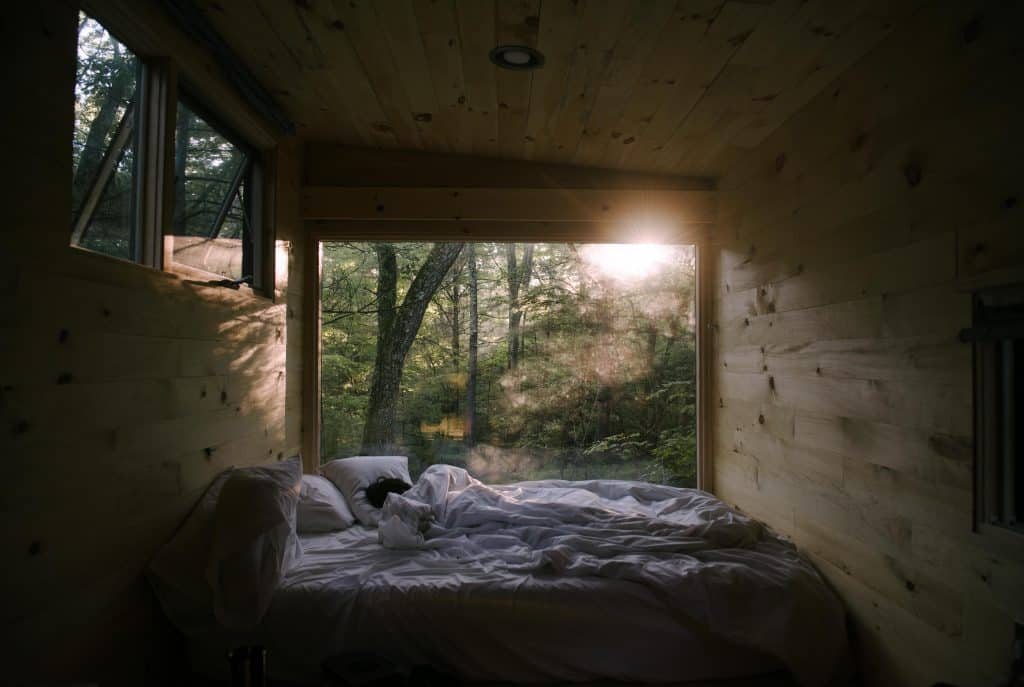Considering the positioning of the bed in relation to the windows, what can be inferred about the priorities in the design of this bedroom? The strategic placement of the bed between two expansive windows underscores a design that celebrates the outdoors, bringing the serene beauty of the forest right into the intimate space of the bedroom. The design maximizes natural light, which bathes the room in a warm glow, especially during the morning hours. This intentional orientation not only promotes psychological well-being, by offering a restful view of nature, but also emphasizes an eco-conscious approach to living, where the room's lighting needs are met by the sun's path, reducing reliance on artificial light. The natural wood finish on the walls complements this close relationship with nature, providing a harmonious and holistic design ethos that is both calming and aesthetically grounded in environmental reverence. 